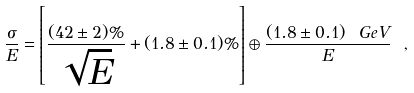<formula> <loc_0><loc_0><loc_500><loc_500>\frac { \sigma } { E } = \left [ \frac { ( 4 2 \pm 2 ) \% } { \sqrt { E } } + ( 1 . 8 \pm 0 . 1 ) \% \right ] \oplus \frac { ( 1 . 8 \pm 0 . 1 ) \ G e V } { E } \ ,</formula> 